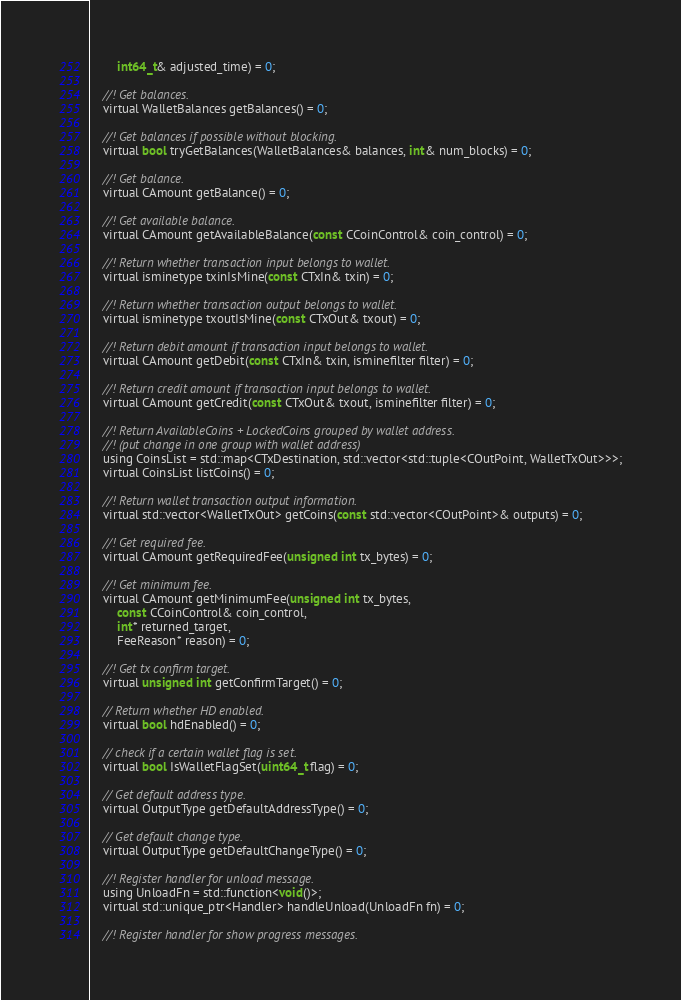<code> <loc_0><loc_0><loc_500><loc_500><_C_>        int64_t& adjusted_time) = 0;

    //! Get balances.
    virtual WalletBalances getBalances() = 0;

    //! Get balances if possible without blocking.
    virtual bool tryGetBalances(WalletBalances& balances, int& num_blocks) = 0;

    //! Get balance.
    virtual CAmount getBalance() = 0;

    //! Get available balance.
    virtual CAmount getAvailableBalance(const CCoinControl& coin_control) = 0;

    //! Return whether transaction input belongs to wallet.
    virtual isminetype txinIsMine(const CTxIn& txin) = 0;

    //! Return whether transaction output belongs to wallet.
    virtual isminetype txoutIsMine(const CTxOut& txout) = 0;

    //! Return debit amount if transaction input belongs to wallet.
    virtual CAmount getDebit(const CTxIn& txin, isminefilter filter) = 0;

    //! Return credit amount if transaction input belongs to wallet.
    virtual CAmount getCredit(const CTxOut& txout, isminefilter filter) = 0;

    //! Return AvailableCoins + LockedCoins grouped by wallet address.
    //! (put change in one group with wallet address)
    using CoinsList = std::map<CTxDestination, std::vector<std::tuple<COutPoint, WalletTxOut>>>;
    virtual CoinsList listCoins() = 0;

    //! Return wallet transaction output information.
    virtual std::vector<WalletTxOut> getCoins(const std::vector<COutPoint>& outputs) = 0;

    //! Get required fee.
    virtual CAmount getRequiredFee(unsigned int tx_bytes) = 0;

    //! Get minimum fee.
    virtual CAmount getMinimumFee(unsigned int tx_bytes,
        const CCoinControl& coin_control,
        int* returned_target,
        FeeReason* reason) = 0;

    //! Get tx confirm target.
    virtual unsigned int getConfirmTarget() = 0;

    // Return whether HD enabled.
    virtual bool hdEnabled() = 0;

    // check if a certain wallet flag is set.
    virtual bool IsWalletFlagSet(uint64_t flag) = 0;

    // Get default address type.
    virtual OutputType getDefaultAddressType() = 0;

    // Get default change type.
    virtual OutputType getDefaultChangeType() = 0;

    //! Register handler for unload message.
    using UnloadFn = std::function<void()>;
    virtual std::unique_ptr<Handler> handleUnload(UnloadFn fn) = 0;

    //! Register handler for show progress messages.</code> 